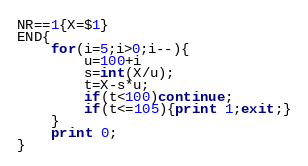<code> <loc_0><loc_0><loc_500><loc_500><_Awk_>NR==1{X=$1}
END{
    for(i=5;i>0;i--){
    	u=100+i
    	s=int(X/u);
        t=X-s*u;
		if(t<100)continue;
        if(t<=105){print 1;exit;}
    }
    print 0;
}</code> 